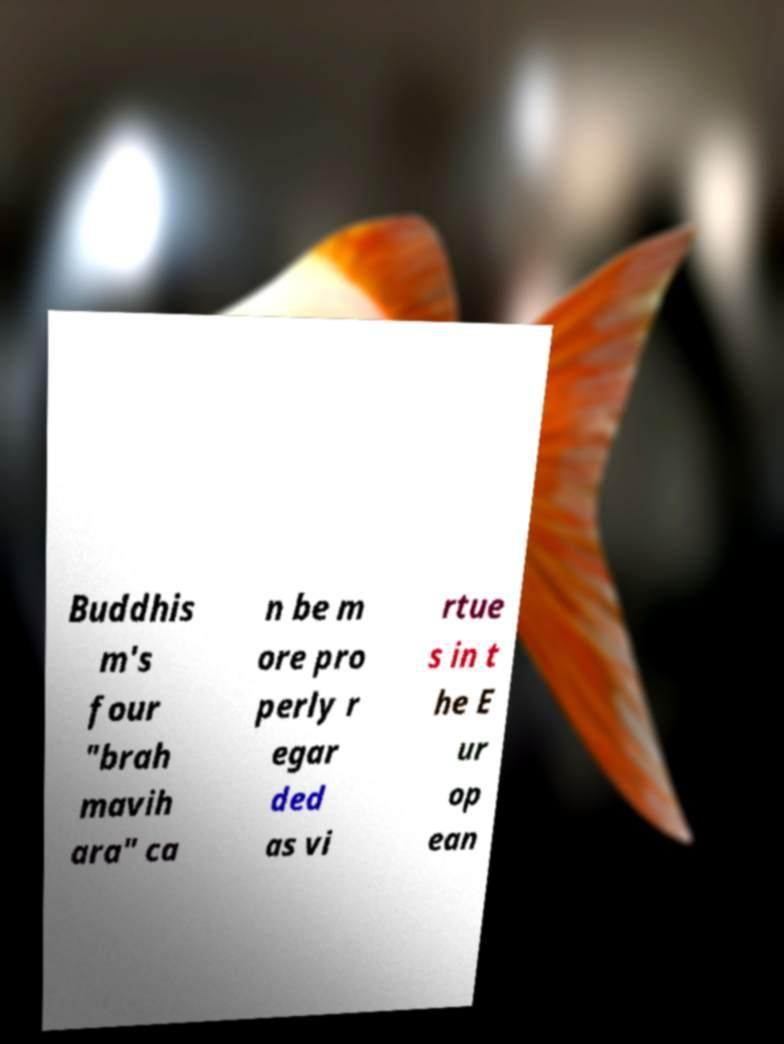Could you extract and type out the text from this image? Buddhis m's four "brah mavih ara" ca n be m ore pro perly r egar ded as vi rtue s in t he E ur op ean 